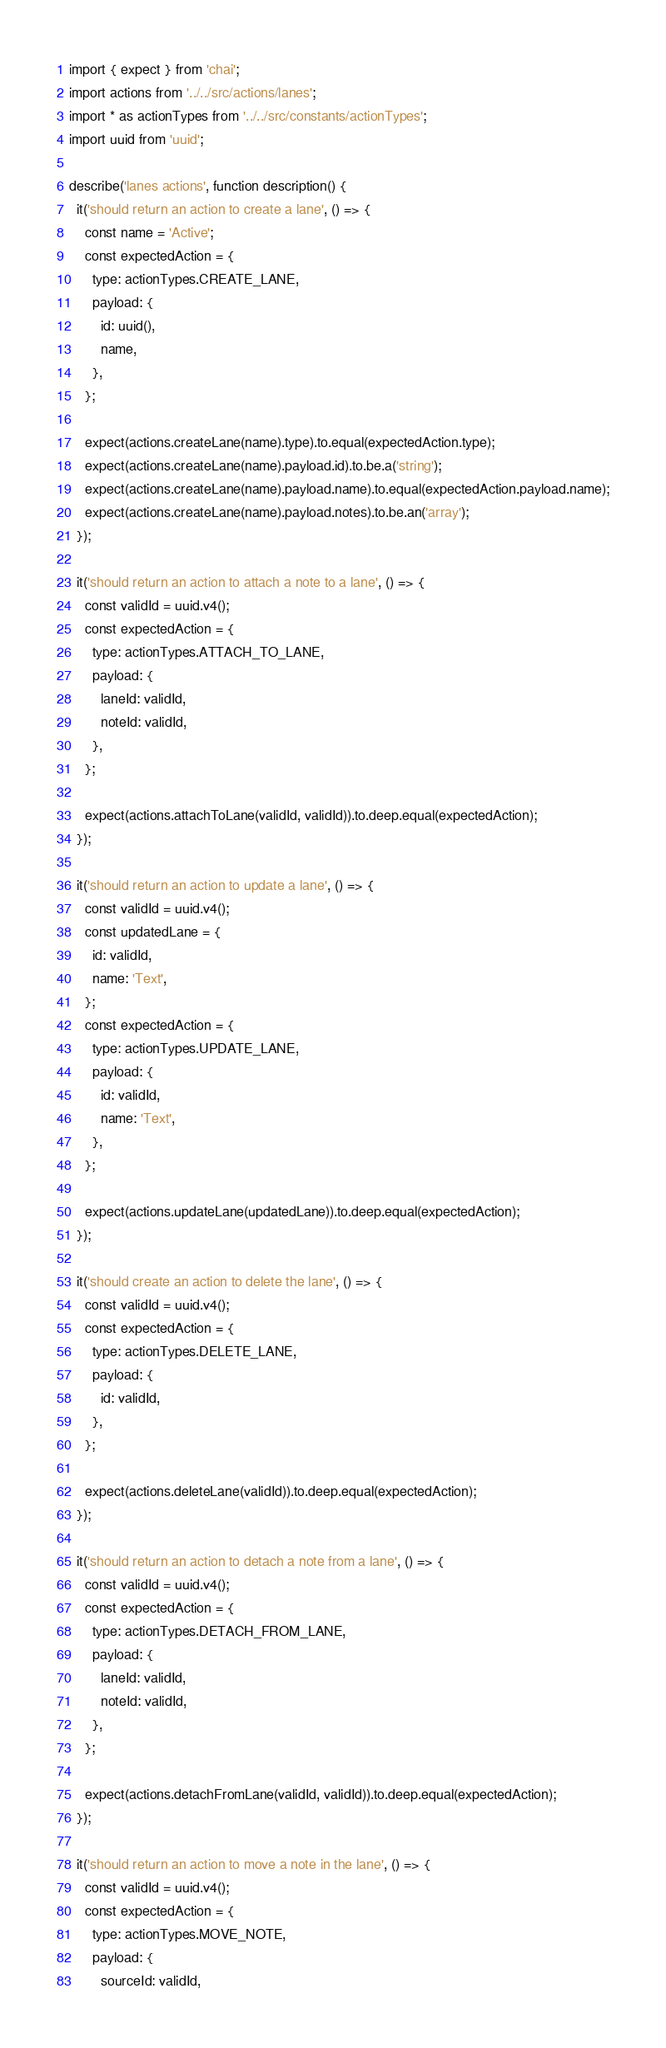Convert code to text. <code><loc_0><loc_0><loc_500><loc_500><_JavaScript_>import { expect } from 'chai';
import actions from '../../src/actions/lanes';
import * as actionTypes from '../../src/constants/actionTypes';
import uuid from 'uuid';

describe('lanes actions', function description() {
  it('should return an action to create a lane', () => {
    const name = 'Active';
    const expectedAction = {
      type: actionTypes.CREATE_LANE,
      payload: {
        id: uuid(),
        name,
      },
    };

    expect(actions.createLane(name).type).to.equal(expectedAction.type);
    expect(actions.createLane(name).payload.id).to.be.a('string');
    expect(actions.createLane(name).payload.name).to.equal(expectedAction.payload.name);
    expect(actions.createLane(name).payload.notes).to.be.an('array');
  });

  it('should return an action to attach a note to a lane', () => {
    const validId = uuid.v4();
    const expectedAction = {
      type: actionTypes.ATTACH_TO_LANE,
      payload: {
        laneId: validId,
        noteId: validId,
      },
    };

    expect(actions.attachToLane(validId, validId)).to.deep.equal(expectedAction);
  });

  it('should return an action to update a lane', () => {
    const validId = uuid.v4();
    const updatedLane = {
      id: validId,
      name: 'Text',
    };
    const expectedAction = {
      type: actionTypes.UPDATE_LANE,
      payload: {
        id: validId,
        name: 'Text',
      },
    };

    expect(actions.updateLane(updatedLane)).to.deep.equal(expectedAction);
  });

  it('should create an action to delete the lane', () => {
    const validId = uuid.v4();
    const expectedAction = {
      type: actionTypes.DELETE_LANE,
      payload: {
        id: validId,
      },
    };

    expect(actions.deleteLane(validId)).to.deep.equal(expectedAction);
  });

  it('should return an action to detach a note from a lane', () => {
    const validId = uuid.v4();
    const expectedAction = {
      type: actionTypes.DETACH_FROM_LANE,
      payload: {
        laneId: validId,
        noteId: validId,
      },
    };

    expect(actions.detachFromLane(validId, validId)).to.deep.equal(expectedAction);
  });

  it('should return an action to move a note in the lane', () => {
    const validId = uuid.v4();
    const expectedAction = {
      type: actionTypes.MOVE_NOTE,
      payload: {
        sourceId: validId,</code> 